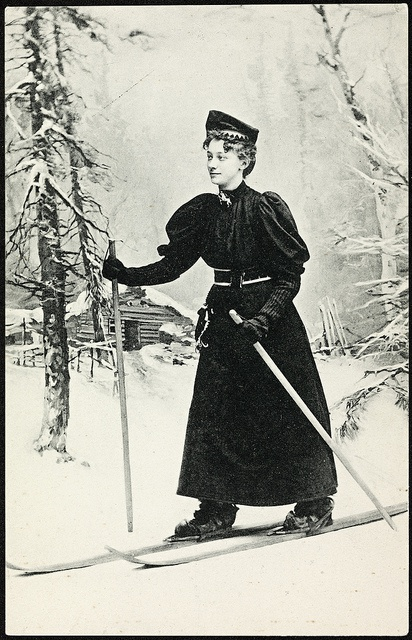Describe the objects in this image and their specific colors. I can see people in black, gray, ivory, and darkgray tones and skis in black, ivory, darkgray, lightgray, and gray tones in this image. 